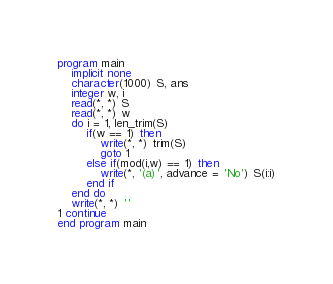Convert code to text. <code><loc_0><loc_0><loc_500><loc_500><_FORTRAN_>program main
	implicit none
    character(1000) S, ans
	integer w, i
	read(*, *) S
	read(*, *) w
	do i = 1, len_trim(S)
		if(w == 1) then
			write(*, *) trim(S)
			goto 1
		else if(mod(i,w) == 1) then
			write(*, '(a)', advance = 'No') S(i:i)
		end if
	end do
	write(*, *) ''
1 continue
end program main</code> 